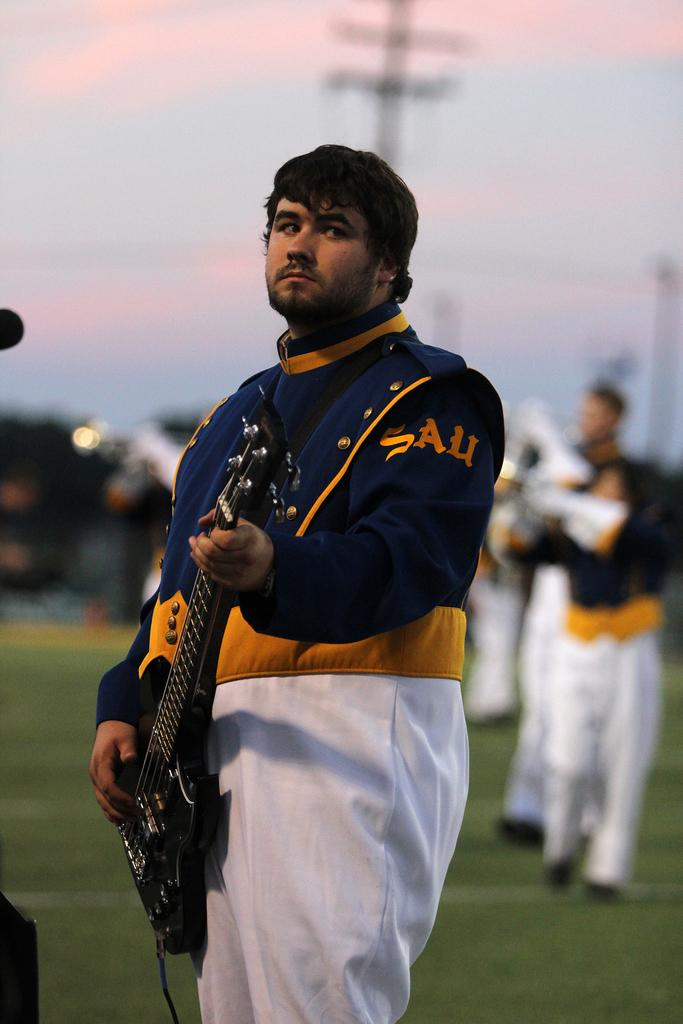What is the main subject of the image? There is a man in the image. What is the man doing in the image? The man is standing in the image. What object is the man holding in the image? The man is holding a guitar in the image. Can you describe the background of the image? There are people visible in the background of the image. What type of tent can be seen in the image? There is no tent present in the image. 